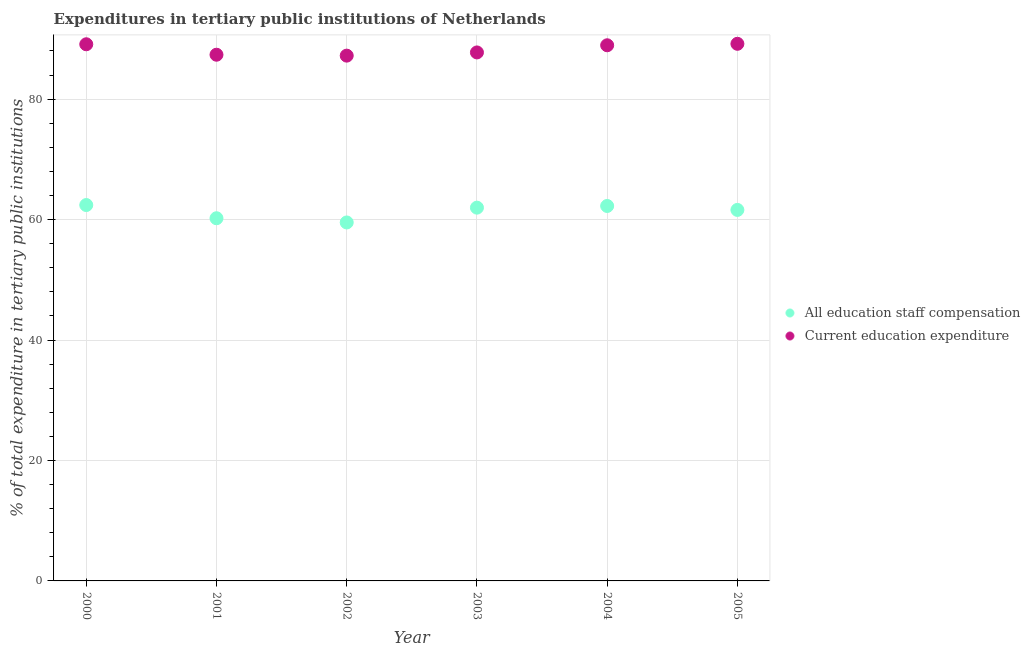Is the number of dotlines equal to the number of legend labels?
Your answer should be compact. Yes. What is the expenditure in staff compensation in 2000?
Keep it short and to the point. 62.41. Across all years, what is the maximum expenditure in staff compensation?
Your answer should be compact. 62.41. Across all years, what is the minimum expenditure in staff compensation?
Your response must be concise. 59.52. In which year was the expenditure in education minimum?
Your answer should be compact. 2002. What is the total expenditure in education in the graph?
Keep it short and to the point. 529.58. What is the difference between the expenditure in staff compensation in 2002 and that in 2004?
Offer a terse response. -2.74. What is the difference between the expenditure in staff compensation in 2002 and the expenditure in education in 2004?
Your answer should be very brief. -29.42. What is the average expenditure in staff compensation per year?
Your response must be concise. 61.33. In the year 2000, what is the difference between the expenditure in staff compensation and expenditure in education?
Give a very brief answer. -26.7. What is the ratio of the expenditure in staff compensation in 2000 to that in 2002?
Your answer should be very brief. 1.05. Is the difference between the expenditure in staff compensation in 2000 and 2003 greater than the difference between the expenditure in education in 2000 and 2003?
Give a very brief answer. No. What is the difference between the highest and the second highest expenditure in staff compensation?
Your response must be concise. 0.15. What is the difference between the highest and the lowest expenditure in staff compensation?
Give a very brief answer. 2.89. Is the sum of the expenditure in education in 2000 and 2003 greater than the maximum expenditure in staff compensation across all years?
Your answer should be compact. Yes. Is the expenditure in staff compensation strictly less than the expenditure in education over the years?
Offer a very short reply. Yes. How many dotlines are there?
Provide a short and direct response. 2. How many years are there in the graph?
Offer a very short reply. 6. What is the difference between two consecutive major ticks on the Y-axis?
Provide a succinct answer. 20. Does the graph contain any zero values?
Keep it short and to the point. No. How many legend labels are there?
Your answer should be compact. 2. What is the title of the graph?
Your answer should be very brief. Expenditures in tertiary public institutions of Netherlands. Does "Transport services" appear as one of the legend labels in the graph?
Your response must be concise. No. What is the label or title of the X-axis?
Provide a short and direct response. Year. What is the label or title of the Y-axis?
Your answer should be compact. % of total expenditure in tertiary public institutions. What is the % of total expenditure in tertiary public institutions in All education staff compensation in 2000?
Offer a very short reply. 62.41. What is the % of total expenditure in tertiary public institutions in Current education expenditure in 2000?
Keep it short and to the point. 89.11. What is the % of total expenditure in tertiary public institutions of All education staff compensation in 2001?
Your answer should be compact. 60.22. What is the % of total expenditure in tertiary public institutions in Current education expenditure in 2001?
Give a very brief answer. 87.37. What is the % of total expenditure in tertiary public institutions of All education staff compensation in 2002?
Make the answer very short. 59.52. What is the % of total expenditure in tertiary public institutions in Current education expenditure in 2002?
Give a very brief answer. 87.22. What is the % of total expenditure in tertiary public institutions in All education staff compensation in 2003?
Ensure brevity in your answer.  61.98. What is the % of total expenditure in tertiary public institutions in Current education expenditure in 2003?
Offer a very short reply. 87.75. What is the % of total expenditure in tertiary public institutions of All education staff compensation in 2004?
Offer a very short reply. 62.26. What is the % of total expenditure in tertiary public institutions in Current education expenditure in 2004?
Keep it short and to the point. 88.94. What is the % of total expenditure in tertiary public institutions of All education staff compensation in 2005?
Keep it short and to the point. 61.6. What is the % of total expenditure in tertiary public institutions of Current education expenditure in 2005?
Give a very brief answer. 89.19. Across all years, what is the maximum % of total expenditure in tertiary public institutions in All education staff compensation?
Provide a succinct answer. 62.41. Across all years, what is the maximum % of total expenditure in tertiary public institutions of Current education expenditure?
Keep it short and to the point. 89.19. Across all years, what is the minimum % of total expenditure in tertiary public institutions in All education staff compensation?
Give a very brief answer. 59.52. Across all years, what is the minimum % of total expenditure in tertiary public institutions of Current education expenditure?
Provide a short and direct response. 87.22. What is the total % of total expenditure in tertiary public institutions of All education staff compensation in the graph?
Offer a very short reply. 368. What is the total % of total expenditure in tertiary public institutions in Current education expenditure in the graph?
Keep it short and to the point. 529.58. What is the difference between the % of total expenditure in tertiary public institutions of All education staff compensation in 2000 and that in 2001?
Make the answer very short. 2.19. What is the difference between the % of total expenditure in tertiary public institutions of Current education expenditure in 2000 and that in 2001?
Give a very brief answer. 1.74. What is the difference between the % of total expenditure in tertiary public institutions of All education staff compensation in 2000 and that in 2002?
Offer a terse response. 2.89. What is the difference between the % of total expenditure in tertiary public institutions of Current education expenditure in 2000 and that in 2002?
Your answer should be compact. 1.89. What is the difference between the % of total expenditure in tertiary public institutions in All education staff compensation in 2000 and that in 2003?
Your response must be concise. 0.43. What is the difference between the % of total expenditure in tertiary public institutions of Current education expenditure in 2000 and that in 2003?
Give a very brief answer. 1.35. What is the difference between the % of total expenditure in tertiary public institutions in All education staff compensation in 2000 and that in 2004?
Provide a short and direct response. 0.15. What is the difference between the % of total expenditure in tertiary public institutions of Current education expenditure in 2000 and that in 2004?
Your response must be concise. 0.17. What is the difference between the % of total expenditure in tertiary public institutions of All education staff compensation in 2000 and that in 2005?
Provide a short and direct response. 0.81. What is the difference between the % of total expenditure in tertiary public institutions in Current education expenditure in 2000 and that in 2005?
Your answer should be very brief. -0.08. What is the difference between the % of total expenditure in tertiary public institutions in All education staff compensation in 2001 and that in 2002?
Keep it short and to the point. 0.7. What is the difference between the % of total expenditure in tertiary public institutions of Current education expenditure in 2001 and that in 2002?
Ensure brevity in your answer.  0.15. What is the difference between the % of total expenditure in tertiary public institutions in All education staff compensation in 2001 and that in 2003?
Offer a terse response. -1.76. What is the difference between the % of total expenditure in tertiary public institutions in Current education expenditure in 2001 and that in 2003?
Your answer should be very brief. -0.38. What is the difference between the % of total expenditure in tertiary public institutions of All education staff compensation in 2001 and that in 2004?
Make the answer very short. -2.04. What is the difference between the % of total expenditure in tertiary public institutions of Current education expenditure in 2001 and that in 2004?
Offer a terse response. -1.57. What is the difference between the % of total expenditure in tertiary public institutions of All education staff compensation in 2001 and that in 2005?
Ensure brevity in your answer.  -1.38. What is the difference between the % of total expenditure in tertiary public institutions in Current education expenditure in 2001 and that in 2005?
Ensure brevity in your answer.  -1.81. What is the difference between the % of total expenditure in tertiary public institutions of All education staff compensation in 2002 and that in 2003?
Your response must be concise. -2.46. What is the difference between the % of total expenditure in tertiary public institutions of Current education expenditure in 2002 and that in 2003?
Make the answer very short. -0.53. What is the difference between the % of total expenditure in tertiary public institutions in All education staff compensation in 2002 and that in 2004?
Give a very brief answer. -2.74. What is the difference between the % of total expenditure in tertiary public institutions in Current education expenditure in 2002 and that in 2004?
Your answer should be very brief. -1.72. What is the difference between the % of total expenditure in tertiary public institutions of All education staff compensation in 2002 and that in 2005?
Make the answer very short. -2.08. What is the difference between the % of total expenditure in tertiary public institutions in Current education expenditure in 2002 and that in 2005?
Keep it short and to the point. -1.96. What is the difference between the % of total expenditure in tertiary public institutions of All education staff compensation in 2003 and that in 2004?
Offer a very short reply. -0.28. What is the difference between the % of total expenditure in tertiary public institutions in Current education expenditure in 2003 and that in 2004?
Provide a short and direct response. -1.19. What is the difference between the % of total expenditure in tertiary public institutions of All education staff compensation in 2003 and that in 2005?
Ensure brevity in your answer.  0.38. What is the difference between the % of total expenditure in tertiary public institutions of Current education expenditure in 2003 and that in 2005?
Your answer should be compact. -1.43. What is the difference between the % of total expenditure in tertiary public institutions in All education staff compensation in 2004 and that in 2005?
Your answer should be compact. 0.66. What is the difference between the % of total expenditure in tertiary public institutions of Current education expenditure in 2004 and that in 2005?
Provide a succinct answer. -0.24. What is the difference between the % of total expenditure in tertiary public institutions in All education staff compensation in 2000 and the % of total expenditure in tertiary public institutions in Current education expenditure in 2001?
Offer a terse response. -24.96. What is the difference between the % of total expenditure in tertiary public institutions of All education staff compensation in 2000 and the % of total expenditure in tertiary public institutions of Current education expenditure in 2002?
Your response must be concise. -24.81. What is the difference between the % of total expenditure in tertiary public institutions of All education staff compensation in 2000 and the % of total expenditure in tertiary public institutions of Current education expenditure in 2003?
Make the answer very short. -25.34. What is the difference between the % of total expenditure in tertiary public institutions in All education staff compensation in 2000 and the % of total expenditure in tertiary public institutions in Current education expenditure in 2004?
Ensure brevity in your answer.  -26.53. What is the difference between the % of total expenditure in tertiary public institutions in All education staff compensation in 2000 and the % of total expenditure in tertiary public institutions in Current education expenditure in 2005?
Ensure brevity in your answer.  -26.77. What is the difference between the % of total expenditure in tertiary public institutions in All education staff compensation in 2001 and the % of total expenditure in tertiary public institutions in Current education expenditure in 2002?
Give a very brief answer. -27. What is the difference between the % of total expenditure in tertiary public institutions in All education staff compensation in 2001 and the % of total expenditure in tertiary public institutions in Current education expenditure in 2003?
Your answer should be compact. -27.53. What is the difference between the % of total expenditure in tertiary public institutions of All education staff compensation in 2001 and the % of total expenditure in tertiary public institutions of Current education expenditure in 2004?
Offer a terse response. -28.72. What is the difference between the % of total expenditure in tertiary public institutions in All education staff compensation in 2001 and the % of total expenditure in tertiary public institutions in Current education expenditure in 2005?
Give a very brief answer. -28.96. What is the difference between the % of total expenditure in tertiary public institutions in All education staff compensation in 2002 and the % of total expenditure in tertiary public institutions in Current education expenditure in 2003?
Provide a short and direct response. -28.23. What is the difference between the % of total expenditure in tertiary public institutions in All education staff compensation in 2002 and the % of total expenditure in tertiary public institutions in Current education expenditure in 2004?
Offer a very short reply. -29.42. What is the difference between the % of total expenditure in tertiary public institutions in All education staff compensation in 2002 and the % of total expenditure in tertiary public institutions in Current education expenditure in 2005?
Offer a terse response. -29.66. What is the difference between the % of total expenditure in tertiary public institutions in All education staff compensation in 2003 and the % of total expenditure in tertiary public institutions in Current education expenditure in 2004?
Offer a terse response. -26.96. What is the difference between the % of total expenditure in tertiary public institutions of All education staff compensation in 2003 and the % of total expenditure in tertiary public institutions of Current education expenditure in 2005?
Provide a short and direct response. -27.21. What is the difference between the % of total expenditure in tertiary public institutions of All education staff compensation in 2004 and the % of total expenditure in tertiary public institutions of Current education expenditure in 2005?
Your answer should be compact. -26.93. What is the average % of total expenditure in tertiary public institutions of All education staff compensation per year?
Offer a very short reply. 61.33. What is the average % of total expenditure in tertiary public institutions in Current education expenditure per year?
Your response must be concise. 88.26. In the year 2000, what is the difference between the % of total expenditure in tertiary public institutions of All education staff compensation and % of total expenditure in tertiary public institutions of Current education expenditure?
Ensure brevity in your answer.  -26.7. In the year 2001, what is the difference between the % of total expenditure in tertiary public institutions of All education staff compensation and % of total expenditure in tertiary public institutions of Current education expenditure?
Keep it short and to the point. -27.15. In the year 2002, what is the difference between the % of total expenditure in tertiary public institutions in All education staff compensation and % of total expenditure in tertiary public institutions in Current education expenditure?
Your answer should be very brief. -27.7. In the year 2003, what is the difference between the % of total expenditure in tertiary public institutions in All education staff compensation and % of total expenditure in tertiary public institutions in Current education expenditure?
Your answer should be very brief. -25.77. In the year 2004, what is the difference between the % of total expenditure in tertiary public institutions in All education staff compensation and % of total expenditure in tertiary public institutions in Current education expenditure?
Your answer should be compact. -26.68. In the year 2005, what is the difference between the % of total expenditure in tertiary public institutions of All education staff compensation and % of total expenditure in tertiary public institutions of Current education expenditure?
Provide a short and direct response. -27.58. What is the ratio of the % of total expenditure in tertiary public institutions of All education staff compensation in 2000 to that in 2001?
Offer a very short reply. 1.04. What is the ratio of the % of total expenditure in tertiary public institutions of Current education expenditure in 2000 to that in 2001?
Offer a terse response. 1.02. What is the ratio of the % of total expenditure in tertiary public institutions in All education staff compensation in 2000 to that in 2002?
Keep it short and to the point. 1.05. What is the ratio of the % of total expenditure in tertiary public institutions in Current education expenditure in 2000 to that in 2002?
Offer a very short reply. 1.02. What is the ratio of the % of total expenditure in tertiary public institutions of Current education expenditure in 2000 to that in 2003?
Your response must be concise. 1.02. What is the ratio of the % of total expenditure in tertiary public institutions in All education staff compensation in 2000 to that in 2005?
Offer a terse response. 1.01. What is the ratio of the % of total expenditure in tertiary public institutions of All education staff compensation in 2001 to that in 2002?
Keep it short and to the point. 1.01. What is the ratio of the % of total expenditure in tertiary public institutions of All education staff compensation in 2001 to that in 2003?
Ensure brevity in your answer.  0.97. What is the ratio of the % of total expenditure in tertiary public institutions in All education staff compensation in 2001 to that in 2004?
Provide a short and direct response. 0.97. What is the ratio of the % of total expenditure in tertiary public institutions in Current education expenditure in 2001 to that in 2004?
Your answer should be very brief. 0.98. What is the ratio of the % of total expenditure in tertiary public institutions of All education staff compensation in 2001 to that in 2005?
Offer a very short reply. 0.98. What is the ratio of the % of total expenditure in tertiary public institutions in Current education expenditure in 2001 to that in 2005?
Ensure brevity in your answer.  0.98. What is the ratio of the % of total expenditure in tertiary public institutions in All education staff compensation in 2002 to that in 2003?
Provide a succinct answer. 0.96. What is the ratio of the % of total expenditure in tertiary public institutions in All education staff compensation in 2002 to that in 2004?
Your answer should be very brief. 0.96. What is the ratio of the % of total expenditure in tertiary public institutions in Current education expenditure in 2002 to that in 2004?
Give a very brief answer. 0.98. What is the ratio of the % of total expenditure in tertiary public institutions of All education staff compensation in 2002 to that in 2005?
Provide a succinct answer. 0.97. What is the ratio of the % of total expenditure in tertiary public institutions in Current education expenditure in 2003 to that in 2004?
Your answer should be very brief. 0.99. What is the ratio of the % of total expenditure in tertiary public institutions of Current education expenditure in 2003 to that in 2005?
Your answer should be compact. 0.98. What is the ratio of the % of total expenditure in tertiary public institutions in All education staff compensation in 2004 to that in 2005?
Provide a short and direct response. 1.01. What is the difference between the highest and the second highest % of total expenditure in tertiary public institutions in All education staff compensation?
Your answer should be compact. 0.15. What is the difference between the highest and the second highest % of total expenditure in tertiary public institutions of Current education expenditure?
Provide a short and direct response. 0.08. What is the difference between the highest and the lowest % of total expenditure in tertiary public institutions of All education staff compensation?
Give a very brief answer. 2.89. What is the difference between the highest and the lowest % of total expenditure in tertiary public institutions of Current education expenditure?
Ensure brevity in your answer.  1.96. 